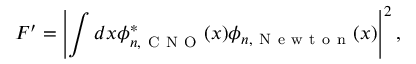Convert formula to latex. <formula><loc_0><loc_0><loc_500><loc_500>F ^ { \prime } = \left | \int d x \phi _ { n , C N O } ^ { * } ( x ) \phi _ { n , N e w t o n } ( x ) \right | ^ { 2 } ,</formula> 